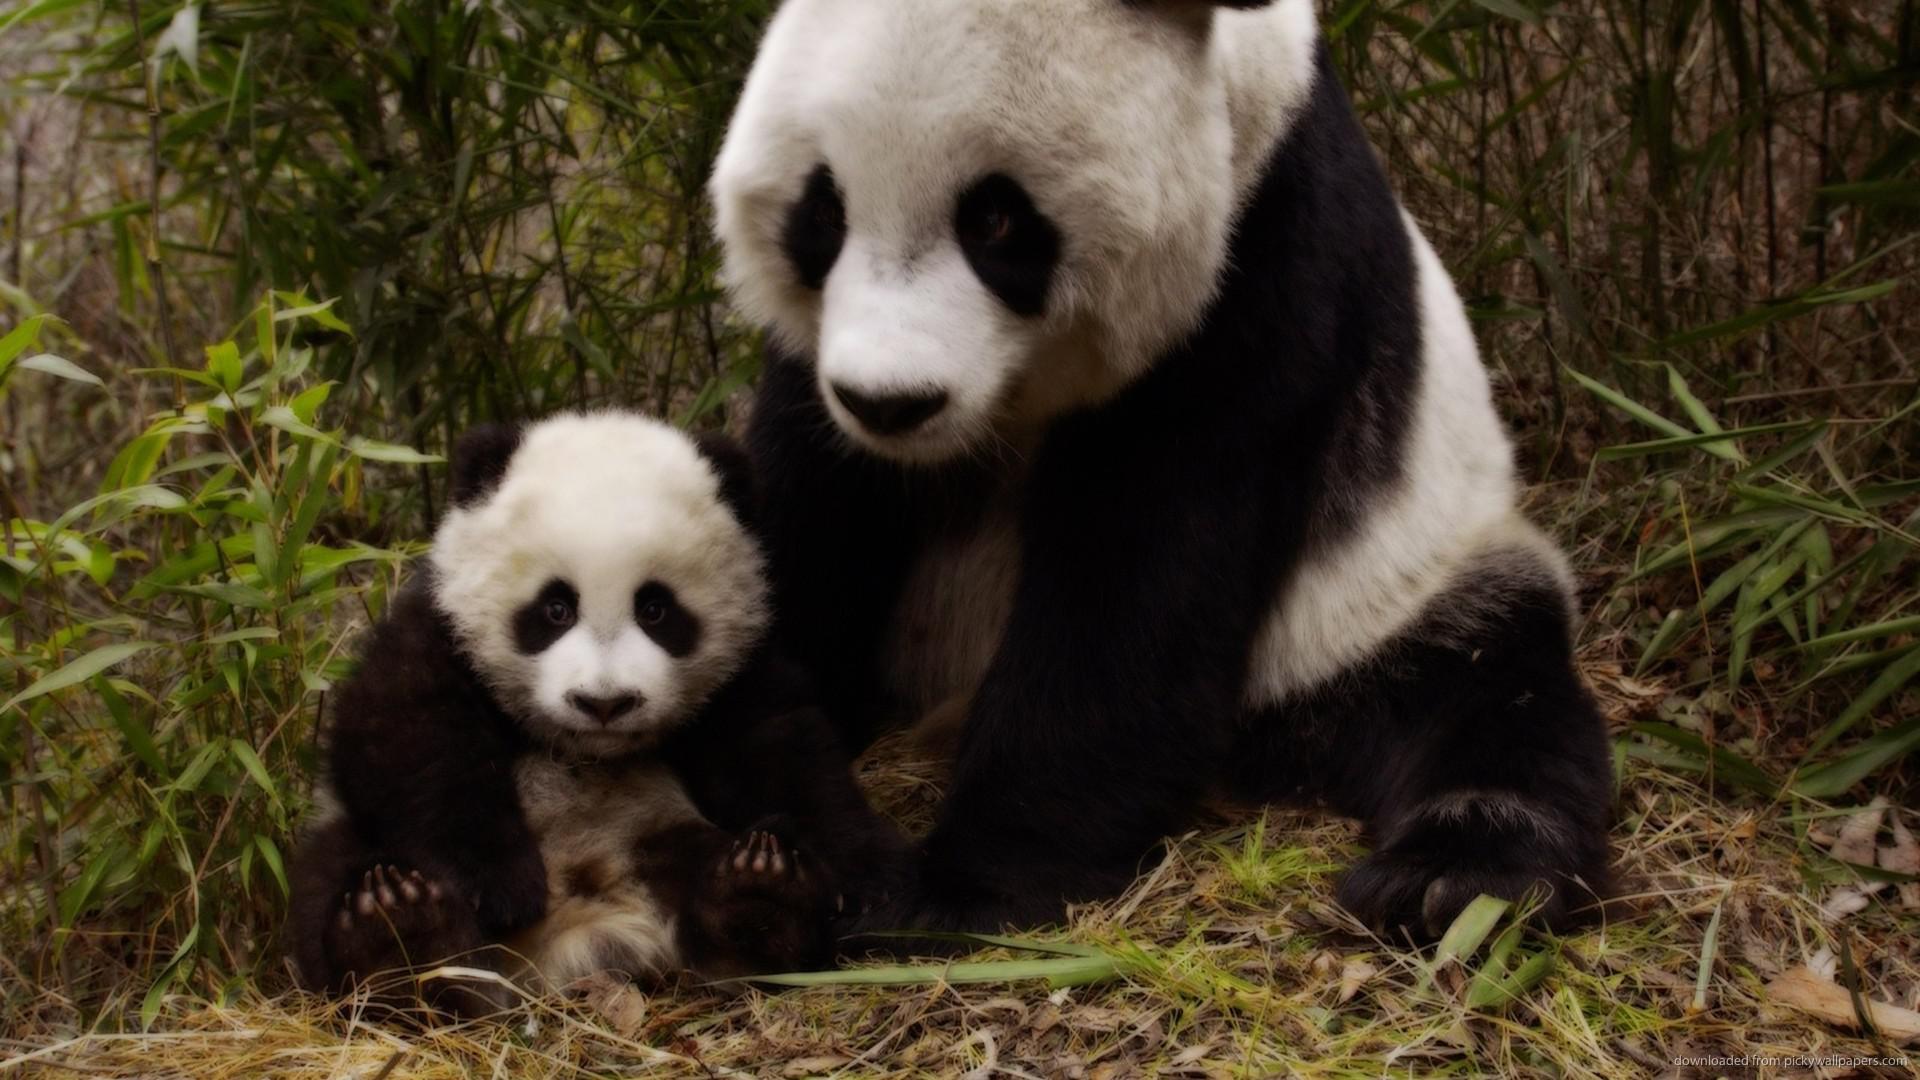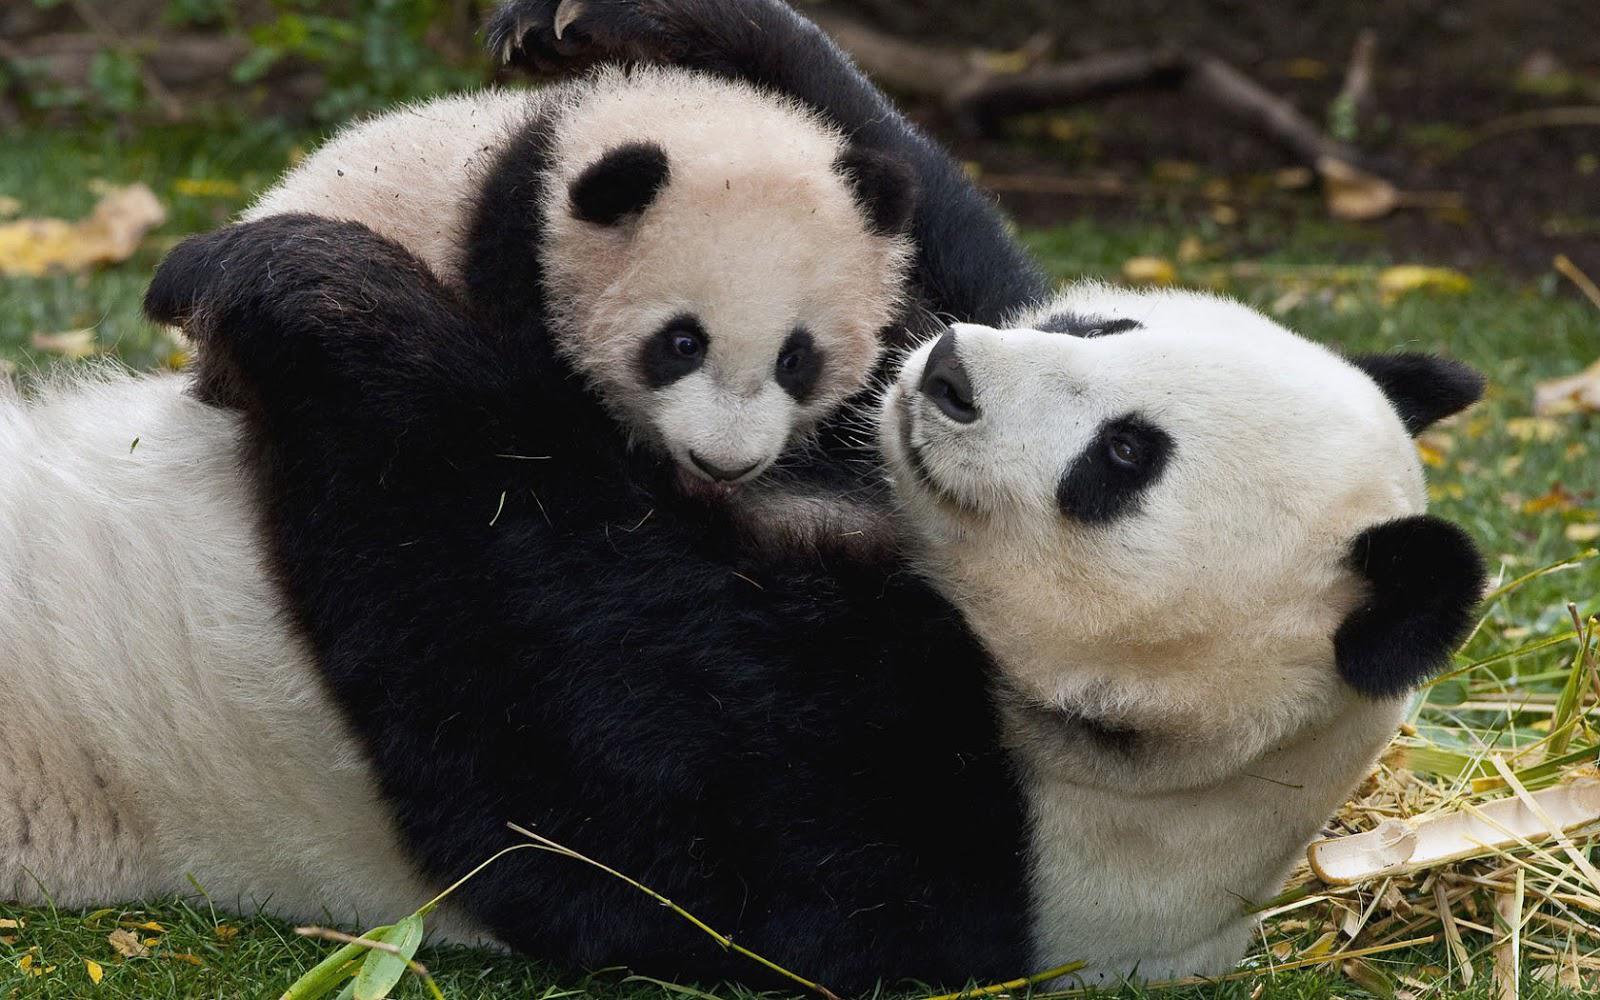The first image is the image on the left, the second image is the image on the right. For the images displayed, is the sentence "An image shows an adult panda on its back, playing with a young panda on top." factually correct? Answer yes or no. Yes. 